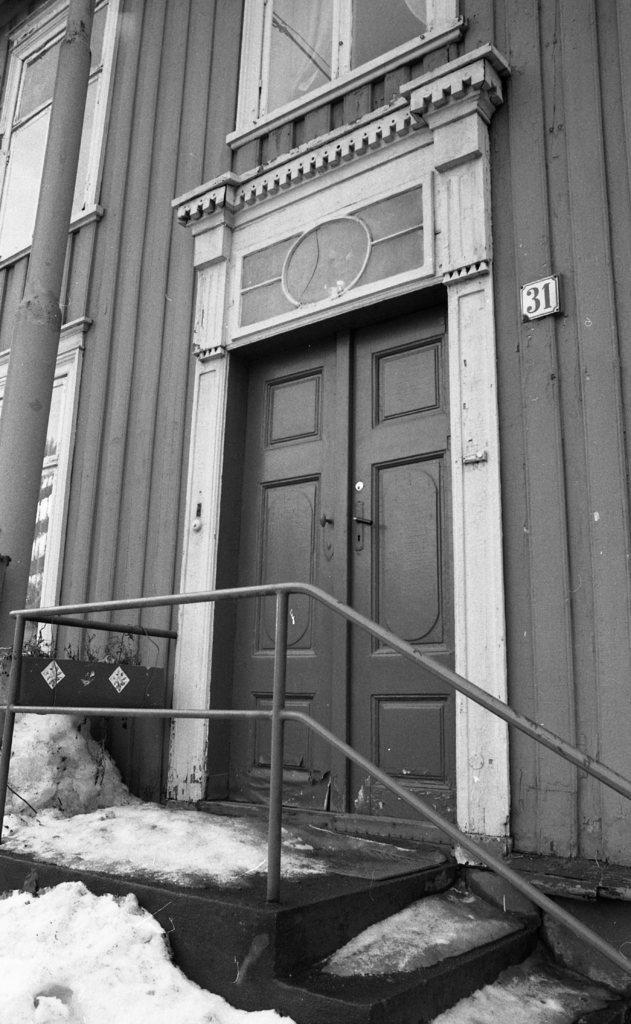How would you summarize this image in a sentence or two? In this picture we can see steps, snow, doors, windows with curtains, pole and the wall. 